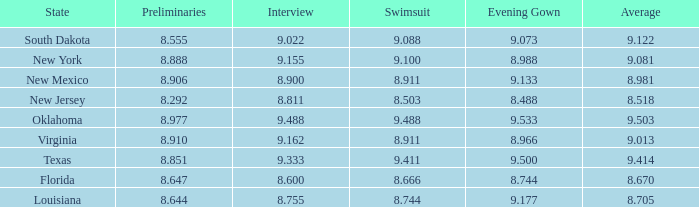Write the full table. {'header': ['State', 'Preliminaries', 'Interview', 'Swimsuit', 'Evening Gown', 'Average'], 'rows': [['South Dakota', '8.555', '9.022', '9.088', '9.073', '9.122'], ['New York', '8.888', '9.155', '9.100', '8.988', '9.081'], ['New Mexico', '8.906', '8.900', '8.911', '9.133', '8.981'], ['New Jersey', '8.292', '8.811', '8.503', '8.488', '8.518'], ['Oklahoma', '8.977', '9.488', '9.488', '9.533', '9.503'], ['Virginia', '8.910', '9.162', '8.911', '8.966', '9.013'], ['Texas', '8.851', '9.333', '9.411', '9.500', '9.414'], ['Florida', '8.647', '8.600', '8.666', '8.744', '8.670'], ['Louisiana', '8.644', '8.755', '8.744', '9.177', '8.705']]}  what's the preliminaries where evening gown is 8.988 8.888. 